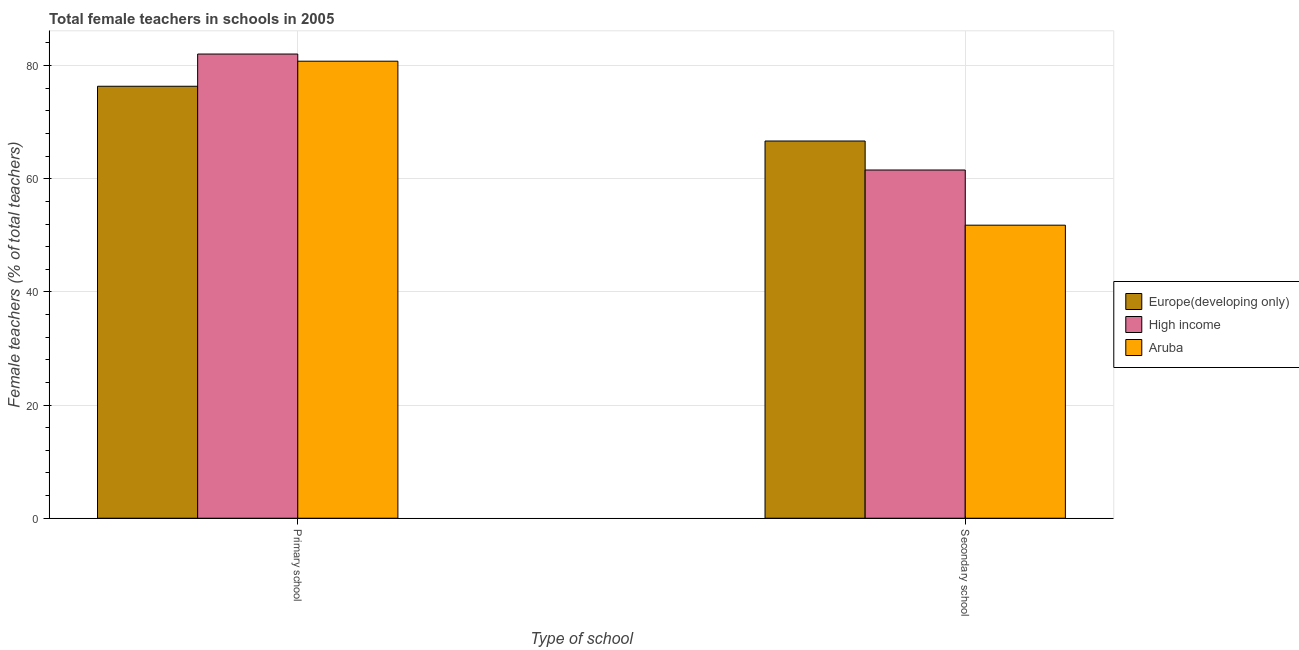Are the number of bars per tick equal to the number of legend labels?
Provide a short and direct response. Yes. Are the number of bars on each tick of the X-axis equal?
Make the answer very short. Yes. How many bars are there on the 2nd tick from the left?
Ensure brevity in your answer.  3. What is the label of the 1st group of bars from the left?
Offer a very short reply. Primary school. What is the percentage of female teachers in primary schools in High income?
Make the answer very short. 82.04. Across all countries, what is the maximum percentage of female teachers in primary schools?
Offer a terse response. 82.04. Across all countries, what is the minimum percentage of female teachers in secondary schools?
Give a very brief answer. 51.79. In which country was the percentage of female teachers in secondary schools maximum?
Provide a short and direct response. Europe(developing only). In which country was the percentage of female teachers in secondary schools minimum?
Offer a very short reply. Aruba. What is the total percentage of female teachers in secondary schools in the graph?
Keep it short and to the point. 180.01. What is the difference between the percentage of female teachers in secondary schools in High income and that in Europe(developing only)?
Make the answer very short. -5.13. What is the difference between the percentage of female teachers in primary schools in High income and the percentage of female teachers in secondary schools in Aruba?
Your answer should be compact. 30.25. What is the average percentage of female teachers in primary schools per country?
Offer a terse response. 79.72. What is the difference between the percentage of female teachers in secondary schools and percentage of female teachers in primary schools in High income?
Ensure brevity in your answer.  -20.5. What is the ratio of the percentage of female teachers in primary schools in High income to that in Europe(developing only)?
Your response must be concise. 1.07. Is the percentage of female teachers in primary schools in High income less than that in Aruba?
Your answer should be compact. No. In how many countries, is the percentage of female teachers in secondary schools greater than the average percentage of female teachers in secondary schools taken over all countries?
Your response must be concise. 2. What does the 1st bar from the left in Primary school represents?
Make the answer very short. Europe(developing only). What does the 1st bar from the right in Secondary school represents?
Your answer should be compact. Aruba. How many countries are there in the graph?
Keep it short and to the point. 3. What is the difference between two consecutive major ticks on the Y-axis?
Your response must be concise. 20. How many legend labels are there?
Make the answer very short. 3. What is the title of the graph?
Offer a very short reply. Total female teachers in schools in 2005. What is the label or title of the X-axis?
Your answer should be very brief. Type of school. What is the label or title of the Y-axis?
Keep it short and to the point. Female teachers (% of total teachers). What is the Female teachers (% of total teachers) of Europe(developing only) in Primary school?
Make the answer very short. 76.34. What is the Female teachers (% of total teachers) in High income in Primary school?
Give a very brief answer. 82.04. What is the Female teachers (% of total teachers) in Aruba in Primary school?
Make the answer very short. 80.78. What is the Female teachers (% of total teachers) of Europe(developing only) in Secondary school?
Your response must be concise. 66.67. What is the Female teachers (% of total teachers) in High income in Secondary school?
Ensure brevity in your answer.  61.54. What is the Female teachers (% of total teachers) in Aruba in Secondary school?
Ensure brevity in your answer.  51.79. Across all Type of school, what is the maximum Female teachers (% of total teachers) in Europe(developing only)?
Your response must be concise. 76.34. Across all Type of school, what is the maximum Female teachers (% of total teachers) in High income?
Provide a succinct answer. 82.04. Across all Type of school, what is the maximum Female teachers (% of total teachers) of Aruba?
Offer a terse response. 80.78. Across all Type of school, what is the minimum Female teachers (% of total teachers) of Europe(developing only)?
Your answer should be very brief. 66.67. Across all Type of school, what is the minimum Female teachers (% of total teachers) in High income?
Your answer should be compact. 61.54. Across all Type of school, what is the minimum Female teachers (% of total teachers) in Aruba?
Your response must be concise. 51.79. What is the total Female teachers (% of total teachers) in Europe(developing only) in the graph?
Make the answer very short. 143.01. What is the total Female teachers (% of total teachers) in High income in the graph?
Your answer should be very brief. 143.58. What is the total Female teachers (% of total teachers) in Aruba in the graph?
Your answer should be very brief. 132.57. What is the difference between the Female teachers (% of total teachers) of Europe(developing only) in Primary school and that in Secondary school?
Keep it short and to the point. 9.67. What is the difference between the Female teachers (% of total teachers) of High income in Primary school and that in Secondary school?
Your response must be concise. 20.5. What is the difference between the Female teachers (% of total teachers) in Aruba in Primary school and that in Secondary school?
Your answer should be compact. 28.98. What is the difference between the Female teachers (% of total teachers) of Europe(developing only) in Primary school and the Female teachers (% of total teachers) of High income in Secondary school?
Offer a very short reply. 14.8. What is the difference between the Female teachers (% of total teachers) in Europe(developing only) in Primary school and the Female teachers (% of total teachers) in Aruba in Secondary school?
Offer a terse response. 24.55. What is the difference between the Female teachers (% of total teachers) in High income in Primary school and the Female teachers (% of total teachers) in Aruba in Secondary school?
Your response must be concise. 30.25. What is the average Female teachers (% of total teachers) of Europe(developing only) per Type of school?
Provide a succinct answer. 71.51. What is the average Female teachers (% of total teachers) of High income per Type of school?
Provide a succinct answer. 71.79. What is the average Female teachers (% of total teachers) of Aruba per Type of school?
Offer a terse response. 66.28. What is the difference between the Female teachers (% of total teachers) of Europe(developing only) and Female teachers (% of total teachers) of High income in Primary school?
Give a very brief answer. -5.7. What is the difference between the Female teachers (% of total teachers) in Europe(developing only) and Female teachers (% of total teachers) in Aruba in Primary school?
Offer a very short reply. -4.43. What is the difference between the Female teachers (% of total teachers) in High income and Female teachers (% of total teachers) in Aruba in Primary school?
Your response must be concise. 1.26. What is the difference between the Female teachers (% of total teachers) of Europe(developing only) and Female teachers (% of total teachers) of High income in Secondary school?
Provide a short and direct response. 5.13. What is the difference between the Female teachers (% of total teachers) of Europe(developing only) and Female teachers (% of total teachers) of Aruba in Secondary school?
Your answer should be very brief. 14.88. What is the difference between the Female teachers (% of total teachers) in High income and Female teachers (% of total teachers) in Aruba in Secondary school?
Offer a terse response. 9.75. What is the ratio of the Female teachers (% of total teachers) in Europe(developing only) in Primary school to that in Secondary school?
Give a very brief answer. 1.15. What is the ratio of the Female teachers (% of total teachers) in High income in Primary school to that in Secondary school?
Make the answer very short. 1.33. What is the ratio of the Female teachers (% of total teachers) of Aruba in Primary school to that in Secondary school?
Offer a very short reply. 1.56. What is the difference between the highest and the second highest Female teachers (% of total teachers) of Europe(developing only)?
Offer a very short reply. 9.67. What is the difference between the highest and the second highest Female teachers (% of total teachers) in High income?
Offer a terse response. 20.5. What is the difference between the highest and the second highest Female teachers (% of total teachers) of Aruba?
Offer a terse response. 28.98. What is the difference between the highest and the lowest Female teachers (% of total teachers) of Europe(developing only)?
Give a very brief answer. 9.67. What is the difference between the highest and the lowest Female teachers (% of total teachers) of High income?
Provide a short and direct response. 20.5. What is the difference between the highest and the lowest Female teachers (% of total teachers) of Aruba?
Keep it short and to the point. 28.98. 